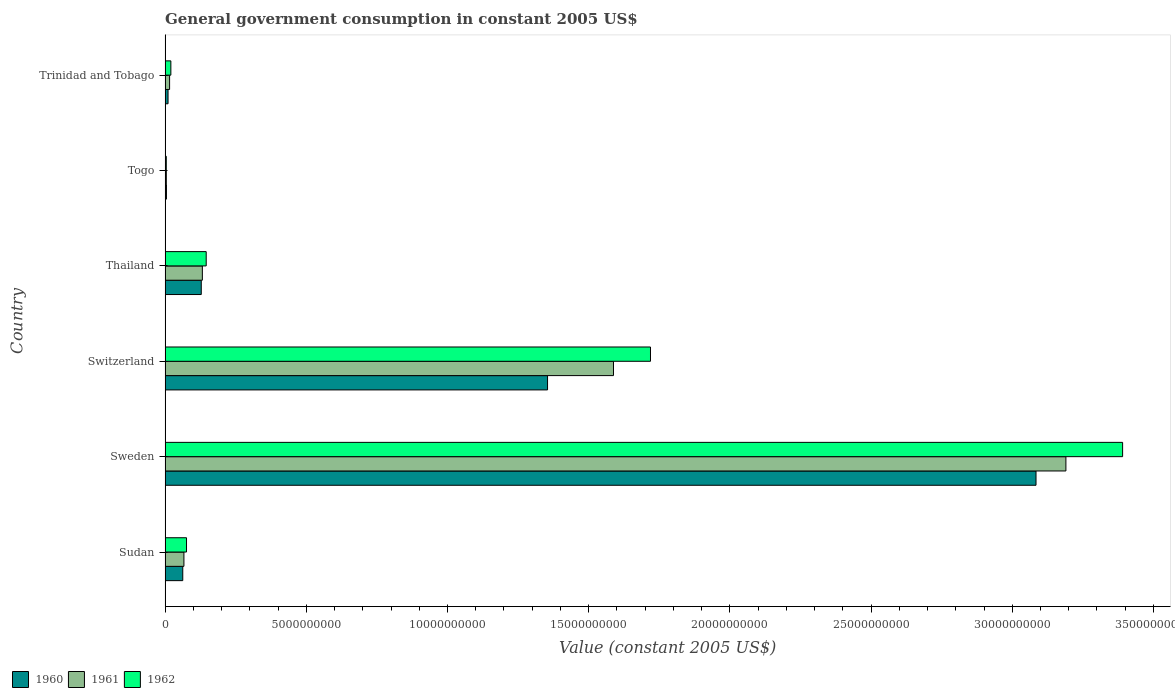Are the number of bars per tick equal to the number of legend labels?
Give a very brief answer. Yes. Are the number of bars on each tick of the Y-axis equal?
Keep it short and to the point. Yes. How many bars are there on the 1st tick from the top?
Ensure brevity in your answer.  3. What is the label of the 1st group of bars from the top?
Offer a very short reply. Trinidad and Tobago. In how many cases, is the number of bars for a given country not equal to the number of legend labels?
Ensure brevity in your answer.  0. What is the government conusmption in 1962 in Sudan?
Give a very brief answer. 7.58e+08. Across all countries, what is the maximum government conusmption in 1962?
Offer a terse response. 3.39e+1. Across all countries, what is the minimum government conusmption in 1961?
Offer a very short reply. 4.33e+07. In which country was the government conusmption in 1962 minimum?
Your answer should be compact. Togo. What is the total government conusmption in 1961 in the graph?
Give a very brief answer. 5.00e+1. What is the difference between the government conusmption in 1961 in Togo and that in Trinidad and Tobago?
Make the answer very short. -1.16e+08. What is the difference between the government conusmption in 1962 in Trinidad and Tobago and the government conusmption in 1961 in Switzerland?
Ensure brevity in your answer.  -1.57e+1. What is the average government conusmption in 1961 per country?
Offer a terse response. 8.33e+09. What is the difference between the government conusmption in 1962 and government conusmption in 1960 in Thailand?
Keep it short and to the point. 1.75e+08. What is the ratio of the government conusmption in 1961 in Thailand to that in Togo?
Your answer should be very brief. 30.49. What is the difference between the highest and the second highest government conusmption in 1961?
Offer a terse response. 1.60e+1. What is the difference between the highest and the lowest government conusmption in 1960?
Your answer should be compact. 3.08e+1. In how many countries, is the government conusmption in 1962 greater than the average government conusmption in 1962 taken over all countries?
Keep it short and to the point. 2. How many countries are there in the graph?
Your response must be concise. 6. What is the difference between two consecutive major ticks on the X-axis?
Your answer should be compact. 5.00e+09. Where does the legend appear in the graph?
Provide a short and direct response. Bottom left. What is the title of the graph?
Make the answer very short. General government consumption in constant 2005 US$. Does "1971" appear as one of the legend labels in the graph?
Make the answer very short. No. What is the label or title of the X-axis?
Offer a terse response. Value (constant 2005 US$). What is the label or title of the Y-axis?
Offer a very short reply. Country. What is the Value (constant 2005 US$) in 1960 in Sudan?
Your answer should be very brief. 6.26e+08. What is the Value (constant 2005 US$) of 1961 in Sudan?
Keep it short and to the point. 6.66e+08. What is the Value (constant 2005 US$) of 1962 in Sudan?
Offer a very short reply. 7.58e+08. What is the Value (constant 2005 US$) in 1960 in Sweden?
Your response must be concise. 3.08e+1. What is the Value (constant 2005 US$) in 1961 in Sweden?
Your answer should be very brief. 3.19e+1. What is the Value (constant 2005 US$) in 1962 in Sweden?
Your response must be concise. 3.39e+1. What is the Value (constant 2005 US$) in 1960 in Switzerland?
Your answer should be compact. 1.35e+1. What is the Value (constant 2005 US$) in 1961 in Switzerland?
Offer a terse response. 1.59e+1. What is the Value (constant 2005 US$) in 1962 in Switzerland?
Make the answer very short. 1.72e+1. What is the Value (constant 2005 US$) in 1960 in Thailand?
Offer a terse response. 1.28e+09. What is the Value (constant 2005 US$) of 1961 in Thailand?
Offer a terse response. 1.32e+09. What is the Value (constant 2005 US$) of 1962 in Thailand?
Make the answer very short. 1.46e+09. What is the Value (constant 2005 US$) of 1960 in Togo?
Provide a short and direct response. 4.78e+07. What is the Value (constant 2005 US$) of 1961 in Togo?
Your answer should be compact. 4.33e+07. What is the Value (constant 2005 US$) in 1962 in Togo?
Make the answer very short. 4.18e+07. What is the Value (constant 2005 US$) of 1960 in Trinidad and Tobago?
Provide a short and direct response. 1.05e+08. What is the Value (constant 2005 US$) of 1961 in Trinidad and Tobago?
Your response must be concise. 1.59e+08. What is the Value (constant 2005 US$) of 1962 in Trinidad and Tobago?
Provide a short and direct response. 2.04e+08. Across all countries, what is the maximum Value (constant 2005 US$) in 1960?
Your answer should be very brief. 3.08e+1. Across all countries, what is the maximum Value (constant 2005 US$) of 1961?
Keep it short and to the point. 3.19e+1. Across all countries, what is the maximum Value (constant 2005 US$) of 1962?
Give a very brief answer. 3.39e+1. Across all countries, what is the minimum Value (constant 2005 US$) in 1960?
Give a very brief answer. 4.78e+07. Across all countries, what is the minimum Value (constant 2005 US$) in 1961?
Your response must be concise. 4.33e+07. Across all countries, what is the minimum Value (constant 2005 US$) in 1962?
Offer a very short reply. 4.18e+07. What is the total Value (constant 2005 US$) of 1960 in the graph?
Offer a very short reply. 4.64e+1. What is the total Value (constant 2005 US$) in 1961 in the graph?
Offer a terse response. 5.00e+1. What is the total Value (constant 2005 US$) in 1962 in the graph?
Provide a short and direct response. 5.36e+1. What is the difference between the Value (constant 2005 US$) in 1960 in Sudan and that in Sweden?
Keep it short and to the point. -3.02e+1. What is the difference between the Value (constant 2005 US$) of 1961 in Sudan and that in Sweden?
Your response must be concise. -3.12e+1. What is the difference between the Value (constant 2005 US$) of 1962 in Sudan and that in Sweden?
Provide a succinct answer. -3.31e+1. What is the difference between the Value (constant 2005 US$) of 1960 in Sudan and that in Switzerland?
Offer a very short reply. -1.29e+1. What is the difference between the Value (constant 2005 US$) of 1961 in Sudan and that in Switzerland?
Keep it short and to the point. -1.52e+1. What is the difference between the Value (constant 2005 US$) of 1962 in Sudan and that in Switzerland?
Provide a succinct answer. -1.64e+1. What is the difference between the Value (constant 2005 US$) in 1960 in Sudan and that in Thailand?
Provide a succinct answer. -6.55e+08. What is the difference between the Value (constant 2005 US$) in 1961 in Sudan and that in Thailand?
Provide a short and direct response. -6.53e+08. What is the difference between the Value (constant 2005 US$) of 1962 in Sudan and that in Thailand?
Provide a short and direct response. -6.97e+08. What is the difference between the Value (constant 2005 US$) of 1960 in Sudan and that in Togo?
Ensure brevity in your answer.  5.78e+08. What is the difference between the Value (constant 2005 US$) of 1961 in Sudan and that in Togo?
Provide a short and direct response. 6.23e+08. What is the difference between the Value (constant 2005 US$) of 1962 in Sudan and that in Togo?
Offer a very short reply. 7.16e+08. What is the difference between the Value (constant 2005 US$) in 1960 in Sudan and that in Trinidad and Tobago?
Keep it short and to the point. 5.21e+08. What is the difference between the Value (constant 2005 US$) of 1961 in Sudan and that in Trinidad and Tobago?
Ensure brevity in your answer.  5.07e+08. What is the difference between the Value (constant 2005 US$) of 1962 in Sudan and that in Trinidad and Tobago?
Ensure brevity in your answer.  5.54e+08. What is the difference between the Value (constant 2005 US$) of 1960 in Sweden and that in Switzerland?
Make the answer very short. 1.73e+1. What is the difference between the Value (constant 2005 US$) in 1961 in Sweden and that in Switzerland?
Provide a succinct answer. 1.60e+1. What is the difference between the Value (constant 2005 US$) of 1962 in Sweden and that in Switzerland?
Offer a terse response. 1.67e+1. What is the difference between the Value (constant 2005 US$) of 1960 in Sweden and that in Thailand?
Provide a succinct answer. 2.96e+1. What is the difference between the Value (constant 2005 US$) of 1961 in Sweden and that in Thailand?
Keep it short and to the point. 3.06e+1. What is the difference between the Value (constant 2005 US$) of 1962 in Sweden and that in Thailand?
Give a very brief answer. 3.25e+1. What is the difference between the Value (constant 2005 US$) in 1960 in Sweden and that in Togo?
Give a very brief answer. 3.08e+1. What is the difference between the Value (constant 2005 US$) in 1961 in Sweden and that in Togo?
Provide a short and direct response. 3.19e+1. What is the difference between the Value (constant 2005 US$) of 1962 in Sweden and that in Togo?
Offer a terse response. 3.39e+1. What is the difference between the Value (constant 2005 US$) in 1960 in Sweden and that in Trinidad and Tobago?
Your response must be concise. 3.07e+1. What is the difference between the Value (constant 2005 US$) of 1961 in Sweden and that in Trinidad and Tobago?
Keep it short and to the point. 3.17e+1. What is the difference between the Value (constant 2005 US$) of 1962 in Sweden and that in Trinidad and Tobago?
Your response must be concise. 3.37e+1. What is the difference between the Value (constant 2005 US$) in 1960 in Switzerland and that in Thailand?
Provide a short and direct response. 1.23e+1. What is the difference between the Value (constant 2005 US$) of 1961 in Switzerland and that in Thailand?
Your answer should be compact. 1.46e+1. What is the difference between the Value (constant 2005 US$) of 1962 in Switzerland and that in Thailand?
Your answer should be very brief. 1.57e+1. What is the difference between the Value (constant 2005 US$) in 1960 in Switzerland and that in Togo?
Provide a succinct answer. 1.35e+1. What is the difference between the Value (constant 2005 US$) of 1961 in Switzerland and that in Togo?
Make the answer very short. 1.58e+1. What is the difference between the Value (constant 2005 US$) of 1962 in Switzerland and that in Togo?
Your answer should be compact. 1.71e+1. What is the difference between the Value (constant 2005 US$) of 1960 in Switzerland and that in Trinidad and Tobago?
Give a very brief answer. 1.34e+1. What is the difference between the Value (constant 2005 US$) of 1961 in Switzerland and that in Trinidad and Tobago?
Make the answer very short. 1.57e+1. What is the difference between the Value (constant 2005 US$) in 1962 in Switzerland and that in Trinidad and Tobago?
Keep it short and to the point. 1.70e+1. What is the difference between the Value (constant 2005 US$) of 1960 in Thailand and that in Togo?
Your answer should be very brief. 1.23e+09. What is the difference between the Value (constant 2005 US$) of 1961 in Thailand and that in Togo?
Keep it short and to the point. 1.28e+09. What is the difference between the Value (constant 2005 US$) in 1962 in Thailand and that in Togo?
Make the answer very short. 1.41e+09. What is the difference between the Value (constant 2005 US$) of 1960 in Thailand and that in Trinidad and Tobago?
Make the answer very short. 1.18e+09. What is the difference between the Value (constant 2005 US$) in 1961 in Thailand and that in Trinidad and Tobago?
Your answer should be very brief. 1.16e+09. What is the difference between the Value (constant 2005 US$) in 1962 in Thailand and that in Trinidad and Tobago?
Offer a terse response. 1.25e+09. What is the difference between the Value (constant 2005 US$) of 1960 in Togo and that in Trinidad and Tobago?
Offer a terse response. -5.67e+07. What is the difference between the Value (constant 2005 US$) of 1961 in Togo and that in Trinidad and Tobago?
Keep it short and to the point. -1.16e+08. What is the difference between the Value (constant 2005 US$) in 1962 in Togo and that in Trinidad and Tobago?
Make the answer very short. -1.62e+08. What is the difference between the Value (constant 2005 US$) of 1960 in Sudan and the Value (constant 2005 US$) of 1961 in Sweden?
Provide a succinct answer. -3.13e+1. What is the difference between the Value (constant 2005 US$) of 1960 in Sudan and the Value (constant 2005 US$) of 1962 in Sweden?
Ensure brevity in your answer.  -3.33e+1. What is the difference between the Value (constant 2005 US$) in 1961 in Sudan and the Value (constant 2005 US$) in 1962 in Sweden?
Keep it short and to the point. -3.32e+1. What is the difference between the Value (constant 2005 US$) of 1960 in Sudan and the Value (constant 2005 US$) of 1961 in Switzerland?
Ensure brevity in your answer.  -1.53e+1. What is the difference between the Value (constant 2005 US$) in 1960 in Sudan and the Value (constant 2005 US$) in 1962 in Switzerland?
Give a very brief answer. -1.66e+1. What is the difference between the Value (constant 2005 US$) of 1961 in Sudan and the Value (constant 2005 US$) of 1962 in Switzerland?
Make the answer very short. -1.65e+1. What is the difference between the Value (constant 2005 US$) in 1960 in Sudan and the Value (constant 2005 US$) in 1961 in Thailand?
Give a very brief answer. -6.94e+08. What is the difference between the Value (constant 2005 US$) of 1960 in Sudan and the Value (constant 2005 US$) of 1962 in Thailand?
Provide a short and direct response. -8.30e+08. What is the difference between the Value (constant 2005 US$) in 1961 in Sudan and the Value (constant 2005 US$) in 1962 in Thailand?
Ensure brevity in your answer.  -7.89e+08. What is the difference between the Value (constant 2005 US$) in 1960 in Sudan and the Value (constant 2005 US$) in 1961 in Togo?
Your response must be concise. 5.82e+08. What is the difference between the Value (constant 2005 US$) in 1960 in Sudan and the Value (constant 2005 US$) in 1962 in Togo?
Keep it short and to the point. 5.84e+08. What is the difference between the Value (constant 2005 US$) in 1961 in Sudan and the Value (constant 2005 US$) in 1962 in Togo?
Offer a terse response. 6.25e+08. What is the difference between the Value (constant 2005 US$) in 1960 in Sudan and the Value (constant 2005 US$) in 1961 in Trinidad and Tobago?
Provide a succinct answer. 4.66e+08. What is the difference between the Value (constant 2005 US$) of 1960 in Sudan and the Value (constant 2005 US$) of 1962 in Trinidad and Tobago?
Ensure brevity in your answer.  4.22e+08. What is the difference between the Value (constant 2005 US$) of 1961 in Sudan and the Value (constant 2005 US$) of 1962 in Trinidad and Tobago?
Make the answer very short. 4.62e+08. What is the difference between the Value (constant 2005 US$) in 1960 in Sweden and the Value (constant 2005 US$) in 1961 in Switzerland?
Ensure brevity in your answer.  1.50e+1. What is the difference between the Value (constant 2005 US$) in 1960 in Sweden and the Value (constant 2005 US$) in 1962 in Switzerland?
Your answer should be very brief. 1.37e+1. What is the difference between the Value (constant 2005 US$) of 1961 in Sweden and the Value (constant 2005 US$) of 1962 in Switzerland?
Make the answer very short. 1.47e+1. What is the difference between the Value (constant 2005 US$) in 1960 in Sweden and the Value (constant 2005 US$) in 1961 in Thailand?
Your response must be concise. 2.95e+1. What is the difference between the Value (constant 2005 US$) of 1960 in Sweden and the Value (constant 2005 US$) of 1962 in Thailand?
Give a very brief answer. 2.94e+1. What is the difference between the Value (constant 2005 US$) in 1961 in Sweden and the Value (constant 2005 US$) in 1962 in Thailand?
Provide a succinct answer. 3.04e+1. What is the difference between the Value (constant 2005 US$) in 1960 in Sweden and the Value (constant 2005 US$) in 1961 in Togo?
Your response must be concise. 3.08e+1. What is the difference between the Value (constant 2005 US$) in 1960 in Sweden and the Value (constant 2005 US$) in 1962 in Togo?
Your response must be concise. 3.08e+1. What is the difference between the Value (constant 2005 US$) in 1961 in Sweden and the Value (constant 2005 US$) in 1962 in Togo?
Your answer should be very brief. 3.19e+1. What is the difference between the Value (constant 2005 US$) of 1960 in Sweden and the Value (constant 2005 US$) of 1961 in Trinidad and Tobago?
Your answer should be very brief. 3.07e+1. What is the difference between the Value (constant 2005 US$) of 1960 in Sweden and the Value (constant 2005 US$) of 1962 in Trinidad and Tobago?
Ensure brevity in your answer.  3.06e+1. What is the difference between the Value (constant 2005 US$) of 1961 in Sweden and the Value (constant 2005 US$) of 1962 in Trinidad and Tobago?
Ensure brevity in your answer.  3.17e+1. What is the difference between the Value (constant 2005 US$) in 1960 in Switzerland and the Value (constant 2005 US$) in 1961 in Thailand?
Keep it short and to the point. 1.22e+1. What is the difference between the Value (constant 2005 US$) of 1960 in Switzerland and the Value (constant 2005 US$) of 1962 in Thailand?
Ensure brevity in your answer.  1.21e+1. What is the difference between the Value (constant 2005 US$) in 1961 in Switzerland and the Value (constant 2005 US$) in 1962 in Thailand?
Your answer should be compact. 1.44e+1. What is the difference between the Value (constant 2005 US$) of 1960 in Switzerland and the Value (constant 2005 US$) of 1961 in Togo?
Your answer should be very brief. 1.35e+1. What is the difference between the Value (constant 2005 US$) of 1960 in Switzerland and the Value (constant 2005 US$) of 1962 in Togo?
Your response must be concise. 1.35e+1. What is the difference between the Value (constant 2005 US$) of 1961 in Switzerland and the Value (constant 2005 US$) of 1962 in Togo?
Ensure brevity in your answer.  1.58e+1. What is the difference between the Value (constant 2005 US$) of 1960 in Switzerland and the Value (constant 2005 US$) of 1961 in Trinidad and Tobago?
Make the answer very short. 1.34e+1. What is the difference between the Value (constant 2005 US$) of 1960 in Switzerland and the Value (constant 2005 US$) of 1962 in Trinidad and Tobago?
Your response must be concise. 1.33e+1. What is the difference between the Value (constant 2005 US$) in 1961 in Switzerland and the Value (constant 2005 US$) in 1962 in Trinidad and Tobago?
Make the answer very short. 1.57e+1. What is the difference between the Value (constant 2005 US$) of 1960 in Thailand and the Value (constant 2005 US$) of 1961 in Togo?
Keep it short and to the point. 1.24e+09. What is the difference between the Value (constant 2005 US$) in 1960 in Thailand and the Value (constant 2005 US$) in 1962 in Togo?
Your answer should be compact. 1.24e+09. What is the difference between the Value (constant 2005 US$) in 1961 in Thailand and the Value (constant 2005 US$) in 1962 in Togo?
Provide a short and direct response. 1.28e+09. What is the difference between the Value (constant 2005 US$) in 1960 in Thailand and the Value (constant 2005 US$) in 1961 in Trinidad and Tobago?
Make the answer very short. 1.12e+09. What is the difference between the Value (constant 2005 US$) in 1960 in Thailand and the Value (constant 2005 US$) in 1962 in Trinidad and Tobago?
Your answer should be very brief. 1.08e+09. What is the difference between the Value (constant 2005 US$) of 1961 in Thailand and the Value (constant 2005 US$) of 1962 in Trinidad and Tobago?
Make the answer very short. 1.12e+09. What is the difference between the Value (constant 2005 US$) of 1960 in Togo and the Value (constant 2005 US$) of 1961 in Trinidad and Tobago?
Keep it short and to the point. -1.12e+08. What is the difference between the Value (constant 2005 US$) in 1960 in Togo and the Value (constant 2005 US$) in 1962 in Trinidad and Tobago?
Make the answer very short. -1.56e+08. What is the difference between the Value (constant 2005 US$) in 1961 in Togo and the Value (constant 2005 US$) in 1962 in Trinidad and Tobago?
Your answer should be very brief. -1.61e+08. What is the average Value (constant 2005 US$) of 1960 per country?
Provide a short and direct response. 7.74e+09. What is the average Value (constant 2005 US$) of 1961 per country?
Offer a very short reply. 8.33e+09. What is the average Value (constant 2005 US$) in 1962 per country?
Give a very brief answer. 8.93e+09. What is the difference between the Value (constant 2005 US$) in 1960 and Value (constant 2005 US$) in 1961 in Sudan?
Your response must be concise. -4.08e+07. What is the difference between the Value (constant 2005 US$) in 1960 and Value (constant 2005 US$) in 1962 in Sudan?
Provide a succinct answer. -1.33e+08. What is the difference between the Value (constant 2005 US$) in 1961 and Value (constant 2005 US$) in 1962 in Sudan?
Your answer should be very brief. -9.18e+07. What is the difference between the Value (constant 2005 US$) of 1960 and Value (constant 2005 US$) of 1961 in Sweden?
Your answer should be compact. -1.06e+09. What is the difference between the Value (constant 2005 US$) of 1960 and Value (constant 2005 US$) of 1962 in Sweden?
Keep it short and to the point. -3.07e+09. What is the difference between the Value (constant 2005 US$) of 1961 and Value (constant 2005 US$) of 1962 in Sweden?
Your answer should be compact. -2.01e+09. What is the difference between the Value (constant 2005 US$) in 1960 and Value (constant 2005 US$) in 1961 in Switzerland?
Make the answer very short. -2.33e+09. What is the difference between the Value (constant 2005 US$) of 1960 and Value (constant 2005 US$) of 1962 in Switzerland?
Offer a very short reply. -3.64e+09. What is the difference between the Value (constant 2005 US$) of 1961 and Value (constant 2005 US$) of 1962 in Switzerland?
Give a very brief answer. -1.31e+09. What is the difference between the Value (constant 2005 US$) of 1960 and Value (constant 2005 US$) of 1961 in Thailand?
Give a very brief answer. -3.88e+07. What is the difference between the Value (constant 2005 US$) in 1960 and Value (constant 2005 US$) in 1962 in Thailand?
Provide a succinct answer. -1.75e+08. What is the difference between the Value (constant 2005 US$) in 1961 and Value (constant 2005 US$) in 1962 in Thailand?
Your response must be concise. -1.36e+08. What is the difference between the Value (constant 2005 US$) of 1960 and Value (constant 2005 US$) of 1961 in Togo?
Give a very brief answer. 4.55e+06. What is the difference between the Value (constant 2005 US$) in 1960 and Value (constant 2005 US$) in 1962 in Togo?
Your answer should be very brief. 6.07e+06. What is the difference between the Value (constant 2005 US$) of 1961 and Value (constant 2005 US$) of 1962 in Togo?
Ensure brevity in your answer.  1.52e+06. What is the difference between the Value (constant 2005 US$) in 1960 and Value (constant 2005 US$) in 1961 in Trinidad and Tobago?
Give a very brief answer. -5.49e+07. What is the difference between the Value (constant 2005 US$) of 1960 and Value (constant 2005 US$) of 1962 in Trinidad and Tobago?
Your answer should be compact. -9.94e+07. What is the difference between the Value (constant 2005 US$) of 1961 and Value (constant 2005 US$) of 1962 in Trinidad and Tobago?
Offer a very short reply. -4.45e+07. What is the ratio of the Value (constant 2005 US$) of 1960 in Sudan to that in Sweden?
Offer a very short reply. 0.02. What is the ratio of the Value (constant 2005 US$) in 1961 in Sudan to that in Sweden?
Ensure brevity in your answer.  0.02. What is the ratio of the Value (constant 2005 US$) in 1962 in Sudan to that in Sweden?
Offer a very short reply. 0.02. What is the ratio of the Value (constant 2005 US$) of 1960 in Sudan to that in Switzerland?
Give a very brief answer. 0.05. What is the ratio of the Value (constant 2005 US$) of 1961 in Sudan to that in Switzerland?
Make the answer very short. 0.04. What is the ratio of the Value (constant 2005 US$) of 1962 in Sudan to that in Switzerland?
Keep it short and to the point. 0.04. What is the ratio of the Value (constant 2005 US$) of 1960 in Sudan to that in Thailand?
Offer a terse response. 0.49. What is the ratio of the Value (constant 2005 US$) in 1961 in Sudan to that in Thailand?
Make the answer very short. 0.51. What is the ratio of the Value (constant 2005 US$) of 1962 in Sudan to that in Thailand?
Offer a terse response. 0.52. What is the ratio of the Value (constant 2005 US$) in 1960 in Sudan to that in Togo?
Give a very brief answer. 13.08. What is the ratio of the Value (constant 2005 US$) in 1961 in Sudan to that in Togo?
Ensure brevity in your answer.  15.4. What is the ratio of the Value (constant 2005 US$) in 1962 in Sudan to that in Togo?
Your answer should be compact. 18.16. What is the ratio of the Value (constant 2005 US$) of 1960 in Sudan to that in Trinidad and Tobago?
Ensure brevity in your answer.  5.98. What is the ratio of the Value (constant 2005 US$) of 1961 in Sudan to that in Trinidad and Tobago?
Your answer should be compact. 4.18. What is the ratio of the Value (constant 2005 US$) in 1962 in Sudan to that in Trinidad and Tobago?
Your response must be concise. 3.72. What is the ratio of the Value (constant 2005 US$) of 1960 in Sweden to that in Switzerland?
Your answer should be very brief. 2.28. What is the ratio of the Value (constant 2005 US$) of 1961 in Sweden to that in Switzerland?
Keep it short and to the point. 2.01. What is the ratio of the Value (constant 2005 US$) in 1962 in Sweden to that in Switzerland?
Give a very brief answer. 1.97. What is the ratio of the Value (constant 2005 US$) in 1960 in Sweden to that in Thailand?
Provide a succinct answer. 24.08. What is the ratio of the Value (constant 2005 US$) in 1961 in Sweden to that in Thailand?
Ensure brevity in your answer.  24.17. What is the ratio of the Value (constant 2005 US$) in 1962 in Sweden to that in Thailand?
Your answer should be very brief. 23.3. What is the ratio of the Value (constant 2005 US$) in 1960 in Sweden to that in Togo?
Give a very brief answer. 644.84. What is the ratio of the Value (constant 2005 US$) of 1961 in Sweden to that in Togo?
Ensure brevity in your answer.  737.18. What is the ratio of the Value (constant 2005 US$) in 1962 in Sweden to that in Togo?
Make the answer very short. 812.08. What is the ratio of the Value (constant 2005 US$) of 1960 in Sweden to that in Trinidad and Tobago?
Your answer should be very brief. 295.02. What is the ratio of the Value (constant 2005 US$) in 1961 in Sweden to that in Trinidad and Tobago?
Offer a terse response. 200.13. What is the ratio of the Value (constant 2005 US$) of 1962 in Sweden to that in Trinidad and Tobago?
Give a very brief answer. 166.29. What is the ratio of the Value (constant 2005 US$) of 1960 in Switzerland to that in Thailand?
Provide a succinct answer. 10.57. What is the ratio of the Value (constant 2005 US$) of 1961 in Switzerland to that in Thailand?
Provide a short and direct response. 12.03. What is the ratio of the Value (constant 2005 US$) in 1962 in Switzerland to that in Thailand?
Offer a terse response. 11.81. What is the ratio of the Value (constant 2005 US$) of 1960 in Switzerland to that in Togo?
Make the answer very short. 283.17. What is the ratio of the Value (constant 2005 US$) in 1961 in Switzerland to that in Togo?
Offer a terse response. 366.94. What is the ratio of the Value (constant 2005 US$) in 1962 in Switzerland to that in Togo?
Provide a succinct answer. 411.66. What is the ratio of the Value (constant 2005 US$) in 1960 in Switzerland to that in Trinidad and Tobago?
Offer a very short reply. 129.56. What is the ratio of the Value (constant 2005 US$) of 1961 in Switzerland to that in Trinidad and Tobago?
Make the answer very short. 99.62. What is the ratio of the Value (constant 2005 US$) of 1962 in Switzerland to that in Trinidad and Tobago?
Your response must be concise. 84.3. What is the ratio of the Value (constant 2005 US$) of 1960 in Thailand to that in Togo?
Offer a very short reply. 26.78. What is the ratio of the Value (constant 2005 US$) of 1961 in Thailand to that in Togo?
Keep it short and to the point. 30.49. What is the ratio of the Value (constant 2005 US$) of 1962 in Thailand to that in Togo?
Offer a terse response. 34.86. What is the ratio of the Value (constant 2005 US$) of 1960 in Thailand to that in Trinidad and Tobago?
Make the answer very short. 12.25. What is the ratio of the Value (constant 2005 US$) of 1961 in Thailand to that in Trinidad and Tobago?
Provide a short and direct response. 8.28. What is the ratio of the Value (constant 2005 US$) of 1962 in Thailand to that in Trinidad and Tobago?
Your answer should be compact. 7.14. What is the ratio of the Value (constant 2005 US$) of 1960 in Togo to that in Trinidad and Tobago?
Keep it short and to the point. 0.46. What is the ratio of the Value (constant 2005 US$) in 1961 in Togo to that in Trinidad and Tobago?
Ensure brevity in your answer.  0.27. What is the ratio of the Value (constant 2005 US$) of 1962 in Togo to that in Trinidad and Tobago?
Provide a short and direct response. 0.2. What is the difference between the highest and the second highest Value (constant 2005 US$) of 1960?
Your answer should be very brief. 1.73e+1. What is the difference between the highest and the second highest Value (constant 2005 US$) of 1961?
Make the answer very short. 1.60e+1. What is the difference between the highest and the second highest Value (constant 2005 US$) of 1962?
Make the answer very short. 1.67e+1. What is the difference between the highest and the lowest Value (constant 2005 US$) in 1960?
Keep it short and to the point. 3.08e+1. What is the difference between the highest and the lowest Value (constant 2005 US$) in 1961?
Offer a very short reply. 3.19e+1. What is the difference between the highest and the lowest Value (constant 2005 US$) in 1962?
Your answer should be very brief. 3.39e+1. 